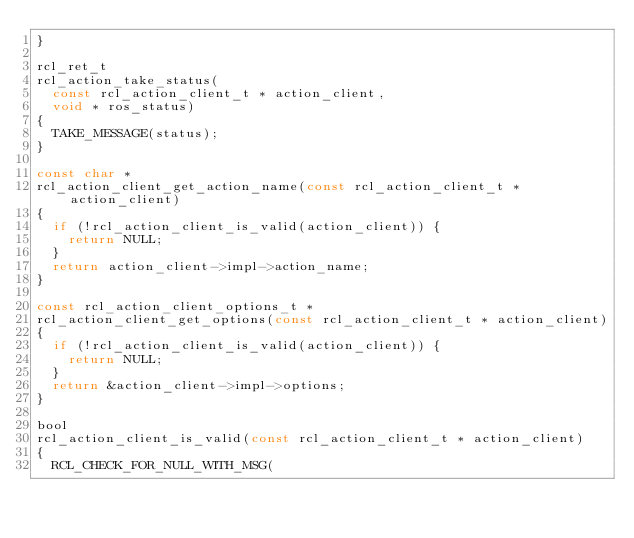<code> <loc_0><loc_0><loc_500><loc_500><_C_>}

rcl_ret_t
rcl_action_take_status(
  const rcl_action_client_t * action_client,
  void * ros_status)
{
  TAKE_MESSAGE(status);
}

const char *
rcl_action_client_get_action_name(const rcl_action_client_t * action_client)
{
  if (!rcl_action_client_is_valid(action_client)) {
    return NULL;
  }
  return action_client->impl->action_name;
}

const rcl_action_client_options_t *
rcl_action_client_get_options(const rcl_action_client_t * action_client)
{
  if (!rcl_action_client_is_valid(action_client)) {
    return NULL;
  }
  return &action_client->impl->options;
}

bool
rcl_action_client_is_valid(const rcl_action_client_t * action_client)
{
  RCL_CHECK_FOR_NULL_WITH_MSG(</code> 